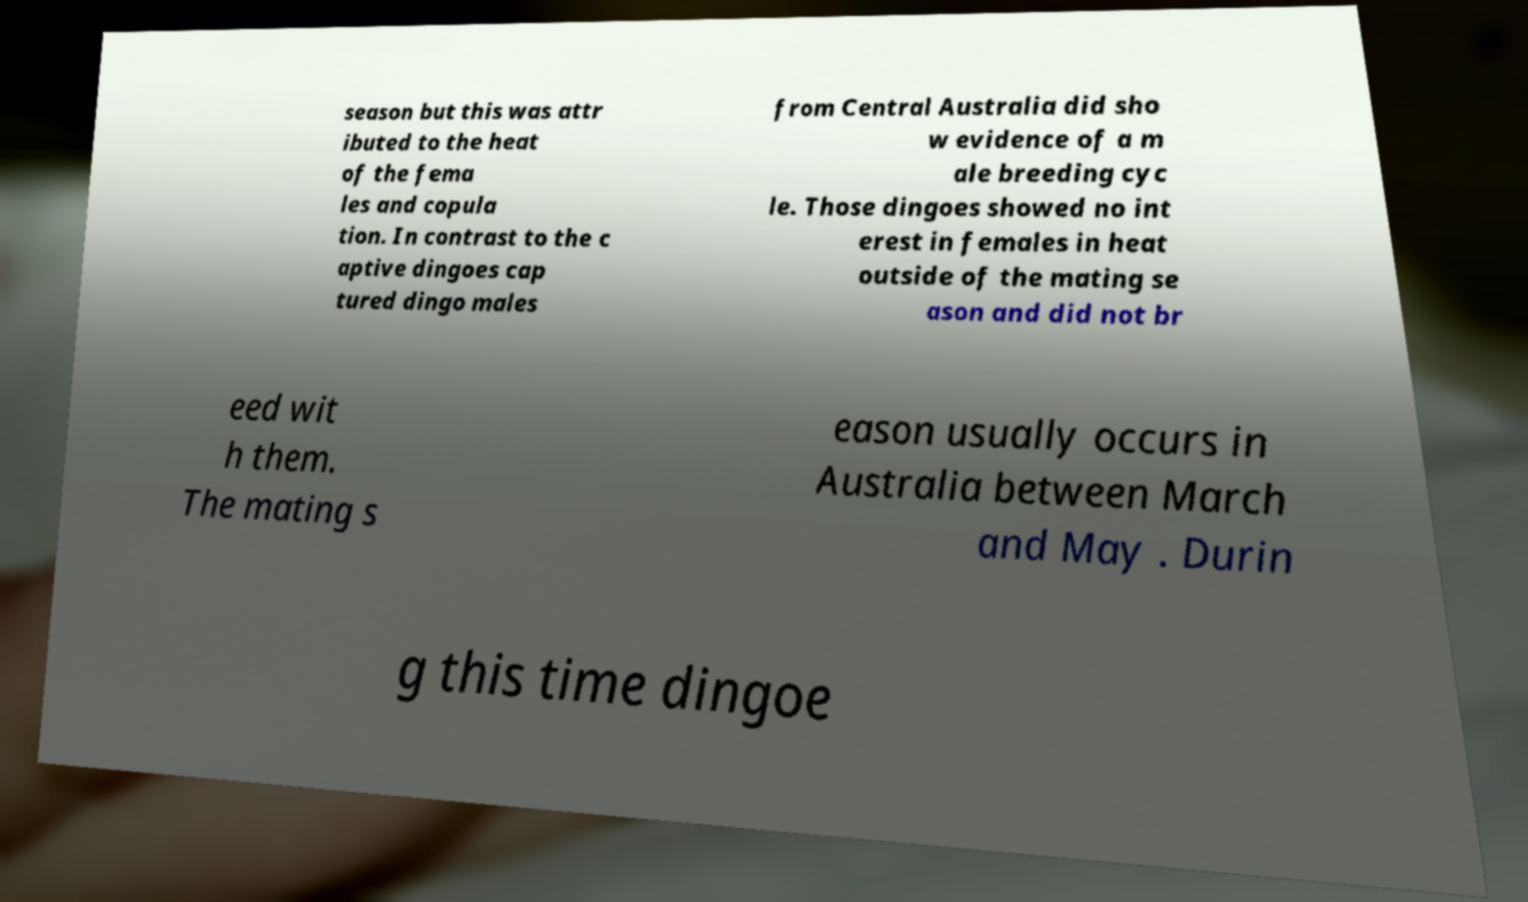Could you assist in decoding the text presented in this image and type it out clearly? season but this was attr ibuted to the heat of the fema les and copula tion. In contrast to the c aptive dingoes cap tured dingo males from Central Australia did sho w evidence of a m ale breeding cyc le. Those dingoes showed no int erest in females in heat outside of the mating se ason and did not br eed wit h them. The mating s eason usually occurs in Australia between March and May . Durin g this time dingoe 